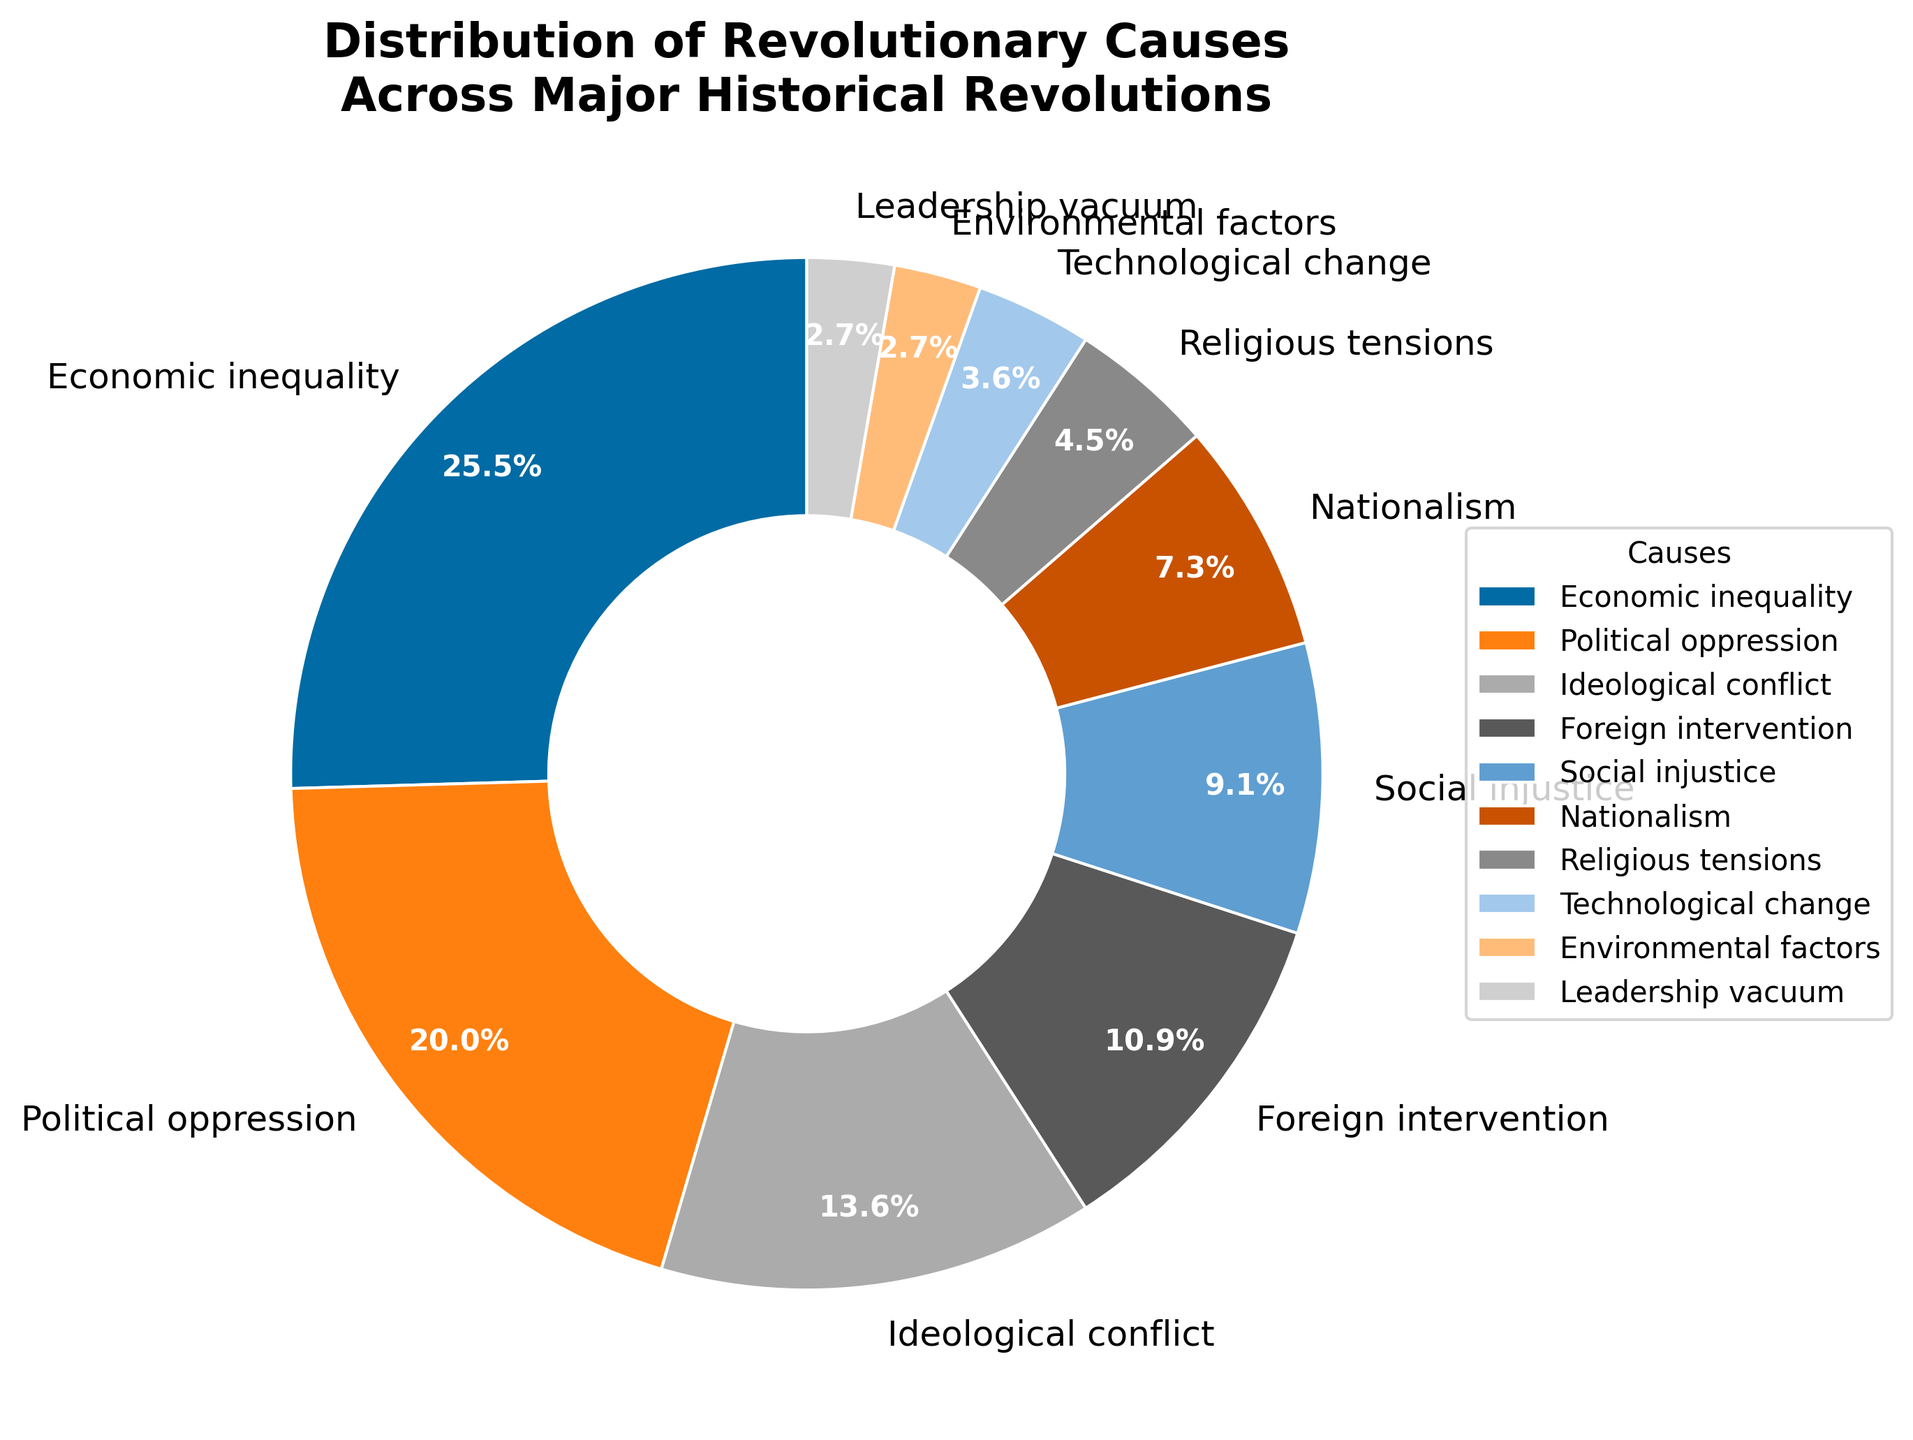What is the most common cause of revolutionary movements according to the pie chart? Look at the largest slice in the pie chart. The label indicates both the cause and its percentage.
Answer: Economic inequality Which cause accounts for the least percentage of revolutionary movements? Find the smallest slice in the pie chart. The label on this smallest slice indicates the cause and its percentage.
Answer: Environmental factors and Leadership vacuum What is the combined percentage of revolutionary movements caused by Social injustice and Nationalism? Locate the slices representing Social injustice and Nationalism. Add their percentages: 10% + 8%.
Answer: 18% Is Political oppression a more significant cause of revolutions than Technological change? Compare the sizes of the slices for Political oppression and Technological change. Look at their percentages: 22% vs. 4%.
Answer: Yes Which causes together make up more than 50% of revolutionary movements? Add the percentages of the causes starting from the largest until the total exceeds 50%. Economic Inequality (28%) + Political Oppression (22%) = 50%. Adding more would exceed 50%.
Answer: Economic inequality, Political oppression 